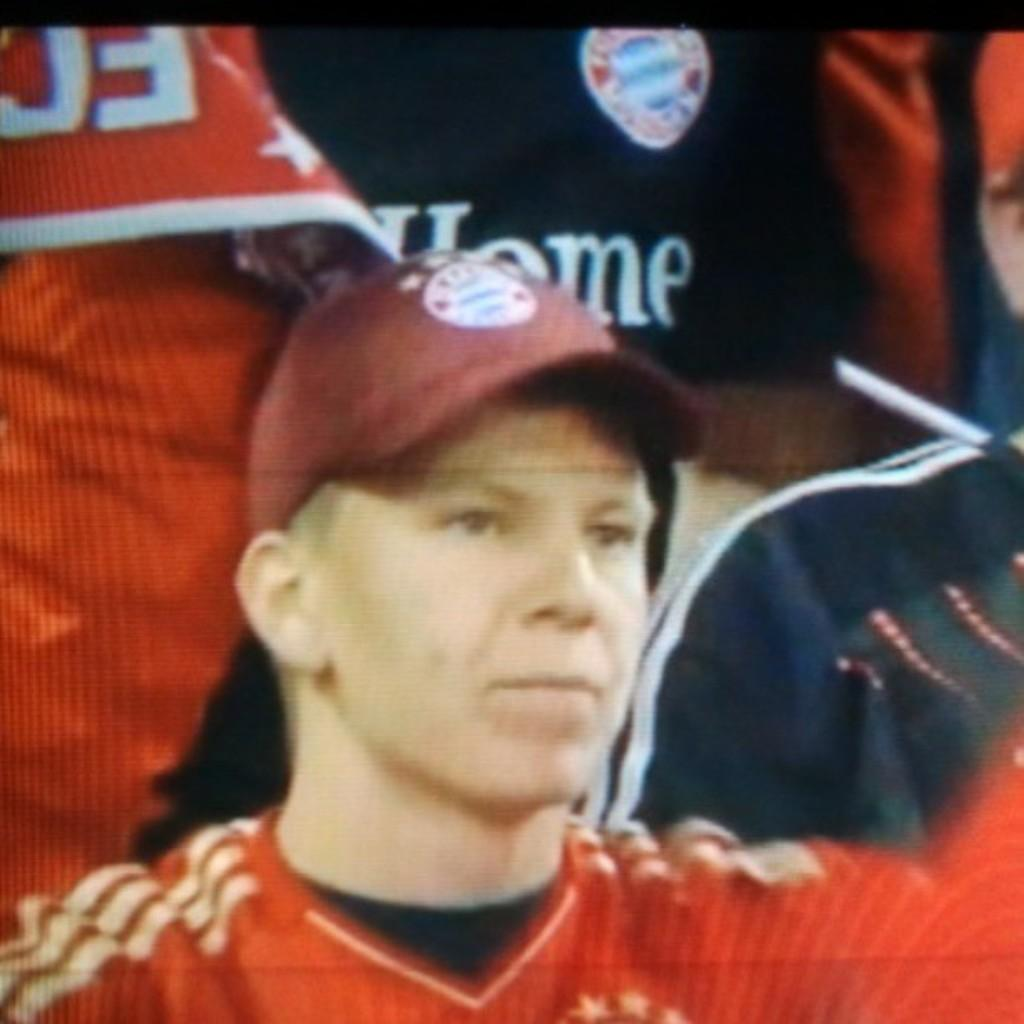How many people are in the image? There are people in the image, but the exact number is not specified. Can you describe the clothing of one of the people in the image? Yes, there is a man wearing a red color T-shirt in the image. What type of headwear is the man wearing? The man is wearing a cap in the image. What is the queen's reaction to the man wearing a red color T-shirt in the image? There is no queen present in the image, so it is not possible to determine her reaction. 